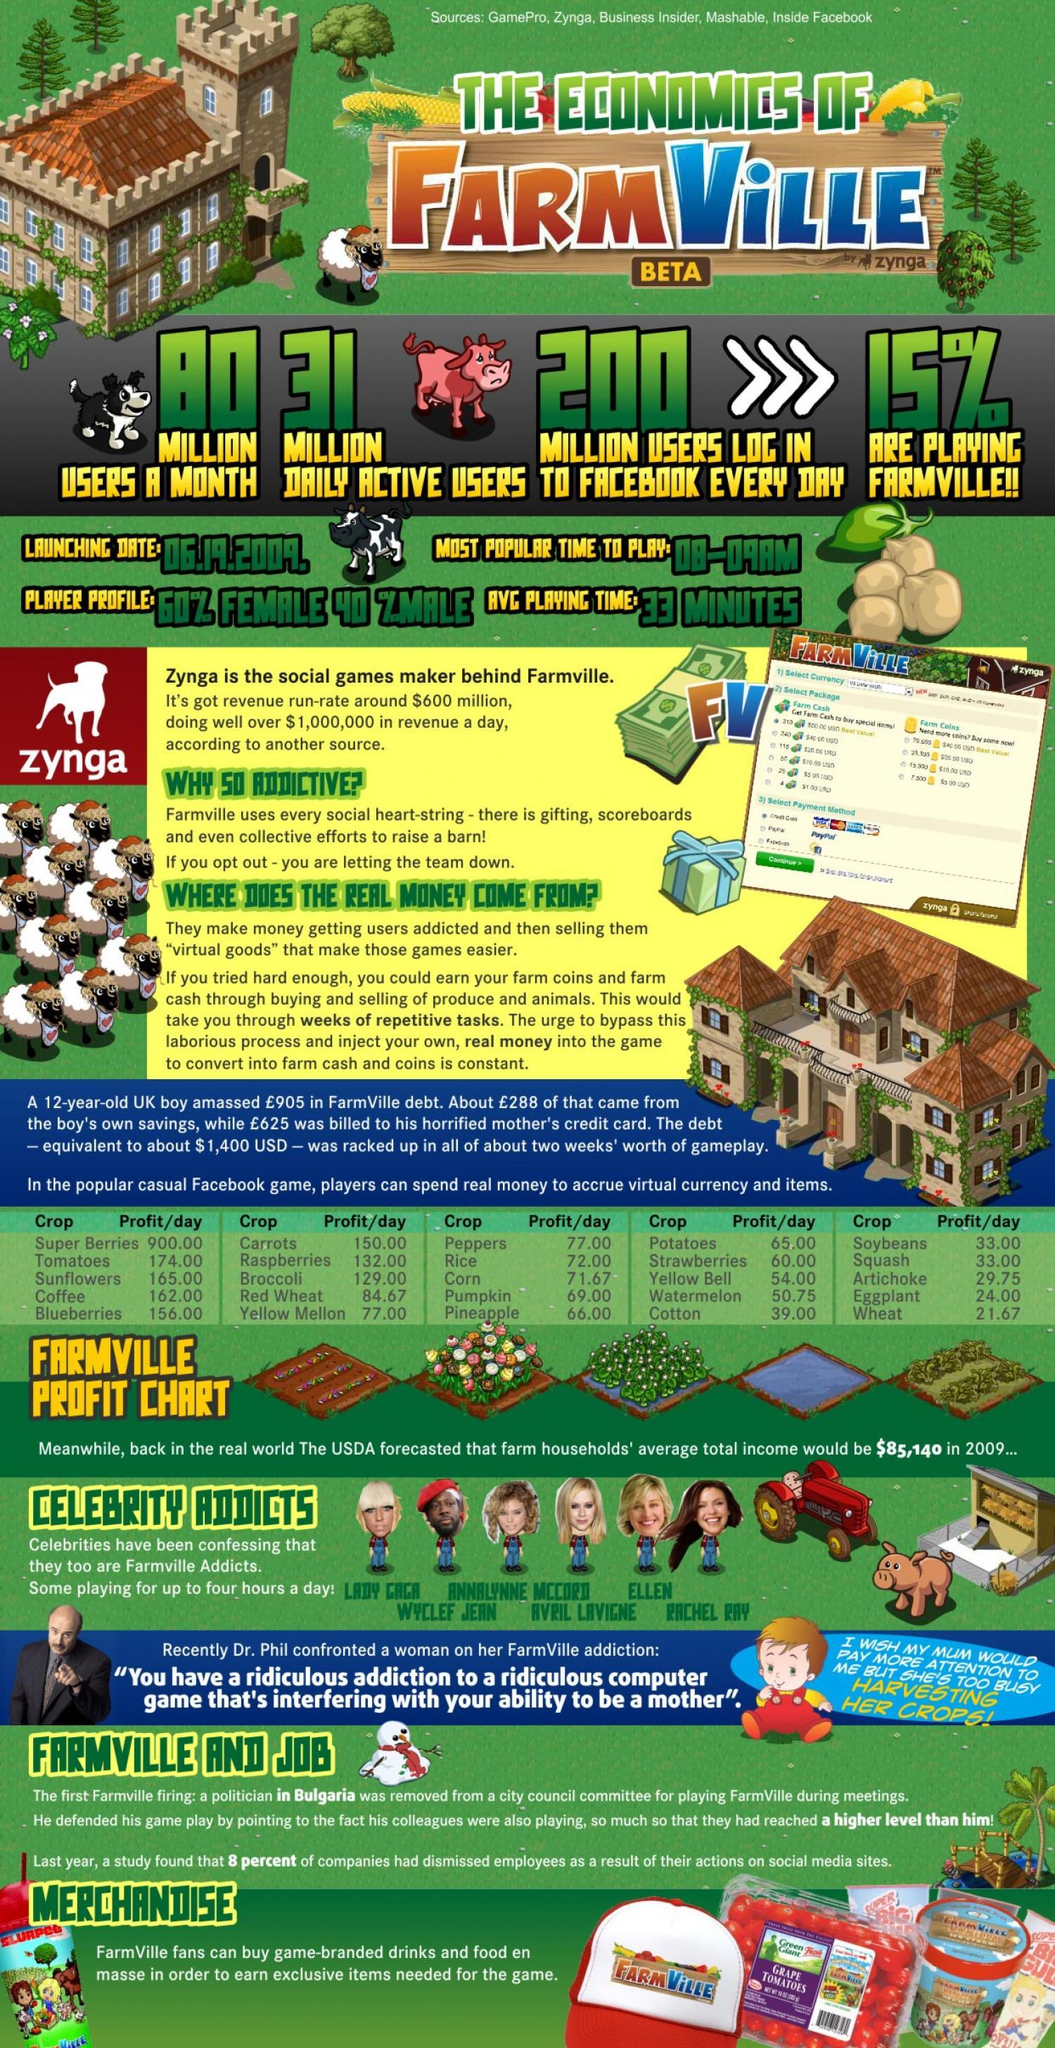What percentage of users are not playing Farmville?
Answer the question with a short phrase. 85 In Farmville profit chart which are the item with profit in between 50-59 per day? watermelon, yellow bell How many users in Farmville in millions are not active daily? 49 In Farmville profit chart which are the item with profit more than 200 per day? super berries How many celebrity addicts are given in this infographic? 6 if we take 10 player profile of Farmville, how many of them would be female? 6 In Farmville profit chart which are the items with profit per day is greater than that of coffee? sunflowers, tomatoes, super berries In Farmville profit chart which are the item with 33.00 profit per day? soybeans, squash How many items are given in profit chart? 25 if we take 10 player profile of Farmville, how many of them would be male? 4 In Farmville profit chart which are the item with less than 30 profit per day? artichoke, eggplant, wheat 